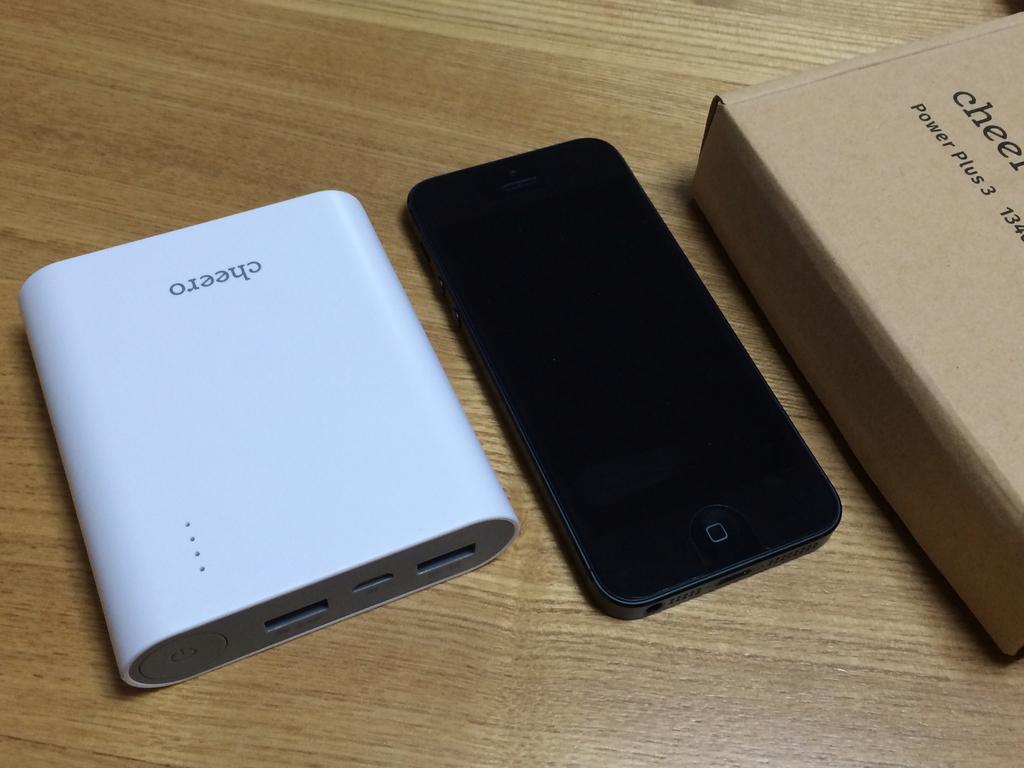What brand of portable battery is this?
Offer a terse response. Cheero. Which power plus version is this?
Your answer should be very brief. 3. 